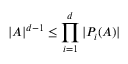Convert formula to latex. <formula><loc_0><loc_0><loc_500><loc_500>| A | ^ { d - 1 } \leq \prod _ { i = 1 } ^ { d } | P _ { i } ( A ) |</formula> 